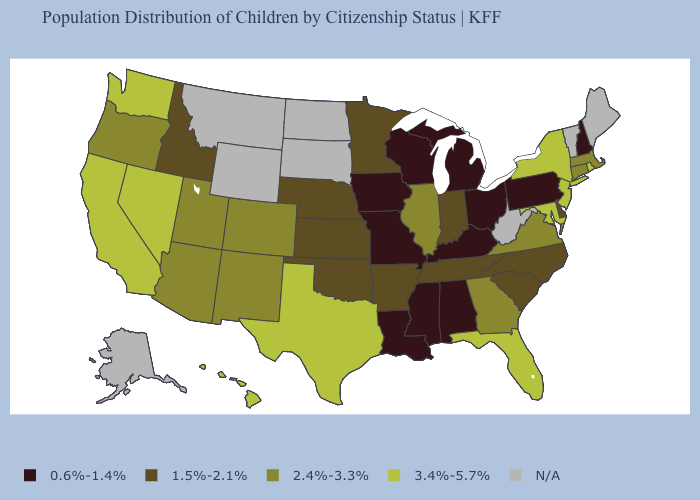What is the value of Kansas?
Quick response, please. 1.5%-2.1%. Which states have the lowest value in the West?
Be succinct. Idaho. What is the value of Rhode Island?
Keep it brief. 3.4%-5.7%. Does the first symbol in the legend represent the smallest category?
Answer briefly. Yes. Is the legend a continuous bar?
Concise answer only. No. What is the value of Minnesota?
Short answer required. 1.5%-2.1%. Does the first symbol in the legend represent the smallest category?
Quick response, please. Yes. Does the first symbol in the legend represent the smallest category?
Keep it brief. Yes. What is the lowest value in the USA?
Quick response, please. 0.6%-1.4%. Among the states that border New Jersey , which have the lowest value?
Answer briefly. Pennsylvania. Does Minnesota have the lowest value in the MidWest?
Write a very short answer. No. Among the states that border California , does Nevada have the highest value?
Answer briefly. Yes. What is the value of Maryland?
Quick response, please. 3.4%-5.7%. What is the highest value in the West ?
Give a very brief answer. 3.4%-5.7%. Which states have the lowest value in the USA?
Answer briefly. Alabama, Iowa, Kentucky, Louisiana, Michigan, Mississippi, Missouri, New Hampshire, Ohio, Pennsylvania, Wisconsin. 